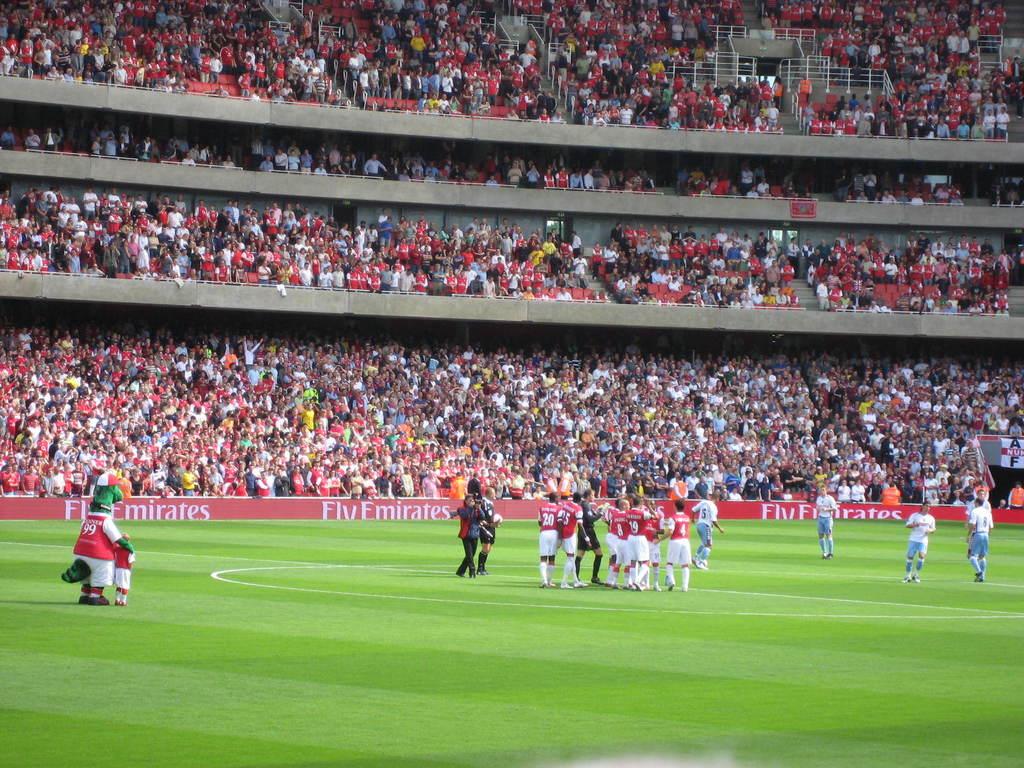What brand is on the walls of the stands in this stadium?
Your response must be concise. Fly emirates. What sport is this?
Give a very brief answer. Answering does not require reading text in the image. 